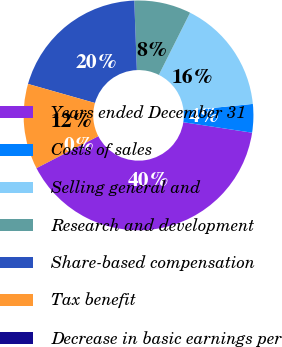Convert chart to OTSL. <chart><loc_0><loc_0><loc_500><loc_500><pie_chart><fcel>Years ended December 31<fcel>Costs of sales<fcel>Selling general and<fcel>Research and development<fcel>Share-based compensation<fcel>Tax benefit<fcel>Decrease in basic earnings per<nl><fcel>39.99%<fcel>4.0%<fcel>16.0%<fcel>8.0%<fcel>20.0%<fcel>12.0%<fcel>0.01%<nl></chart> 